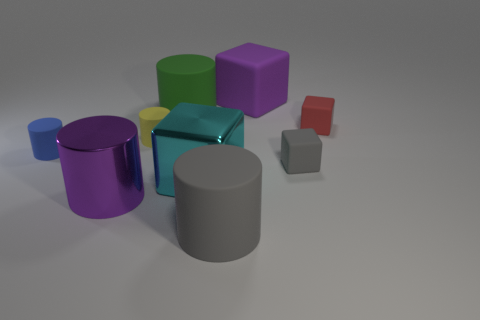What is the material of the block that is the same color as the large metal cylinder?
Offer a terse response. Rubber. What number of big metallic objects are to the right of the metal cube?
Make the answer very short. 0. Do the metal thing on the right side of the big purple metal thing and the small matte cylinder to the right of the tiny blue rubber thing have the same color?
Offer a very short reply. No. What is the color of the other large matte thing that is the same shape as the red thing?
Make the answer very short. Purple. Are there any other things that are the same shape as the yellow thing?
Your answer should be compact. Yes. There is a big gray matte object in front of the small red thing; does it have the same shape as the thing behind the green thing?
Offer a very short reply. No. There is a blue object; is it the same size as the gray object behind the cyan object?
Offer a terse response. Yes. Are there more gray blocks than large matte cylinders?
Offer a very short reply. No. Is the big purple thing that is in front of the purple matte thing made of the same material as the large cube that is in front of the big green cylinder?
Give a very brief answer. Yes. What is the material of the tiny red object?
Provide a short and direct response. Rubber. 